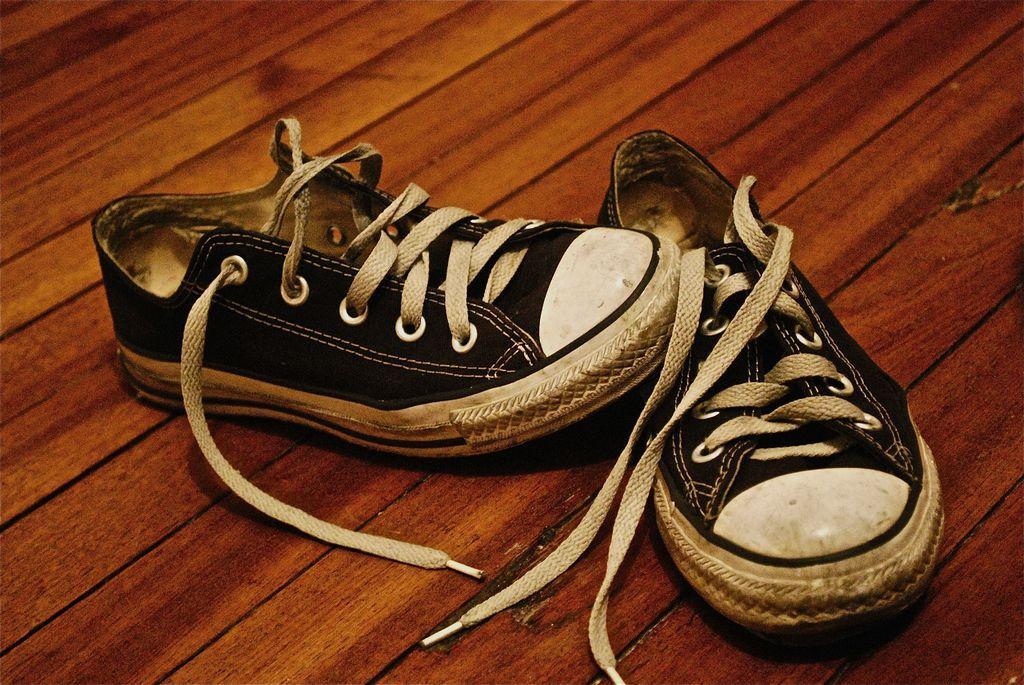In one or two sentences, can you explain what this image depicts? In the picture I can see a pair of black color shoes are kept on the wooden surface. 